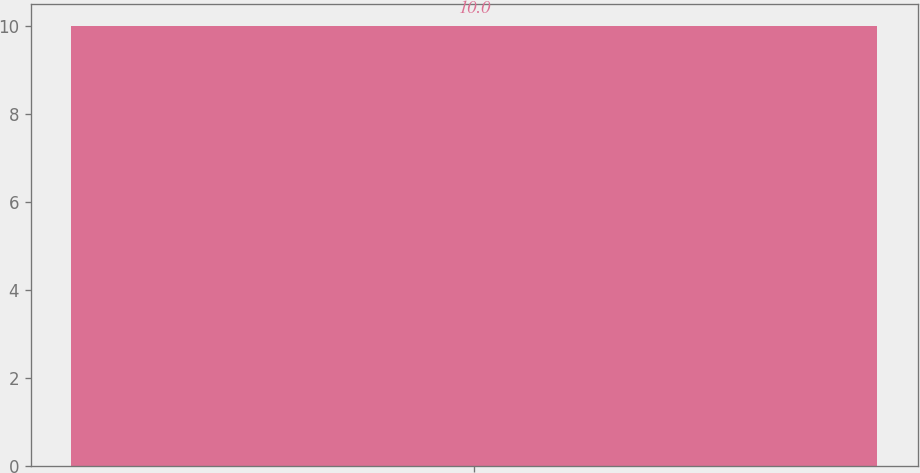<chart> <loc_0><loc_0><loc_500><loc_500><bar_chart><ecel><nl><fcel>10<nl></chart> 